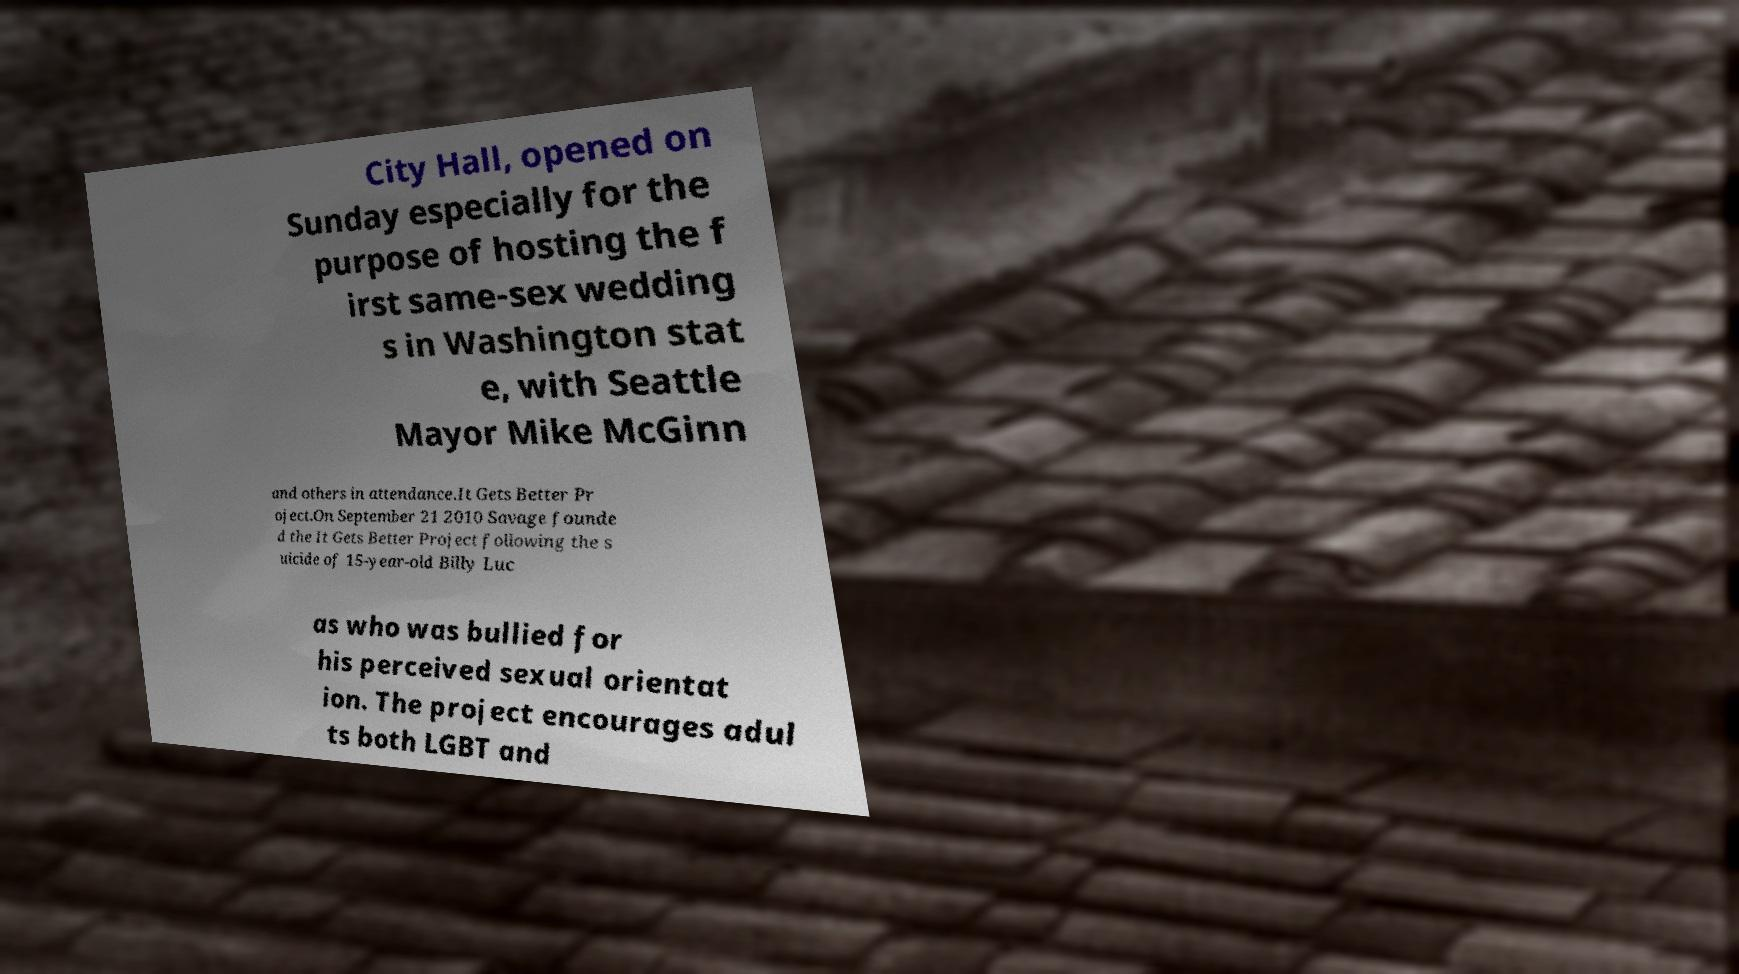What messages or text are displayed in this image? I need them in a readable, typed format. City Hall, opened on Sunday especially for the purpose of hosting the f irst same-sex wedding s in Washington stat e, with Seattle Mayor Mike McGinn and others in attendance.It Gets Better Pr oject.On September 21 2010 Savage founde d the It Gets Better Project following the s uicide of 15-year-old Billy Luc as who was bullied for his perceived sexual orientat ion. The project encourages adul ts both LGBT and 